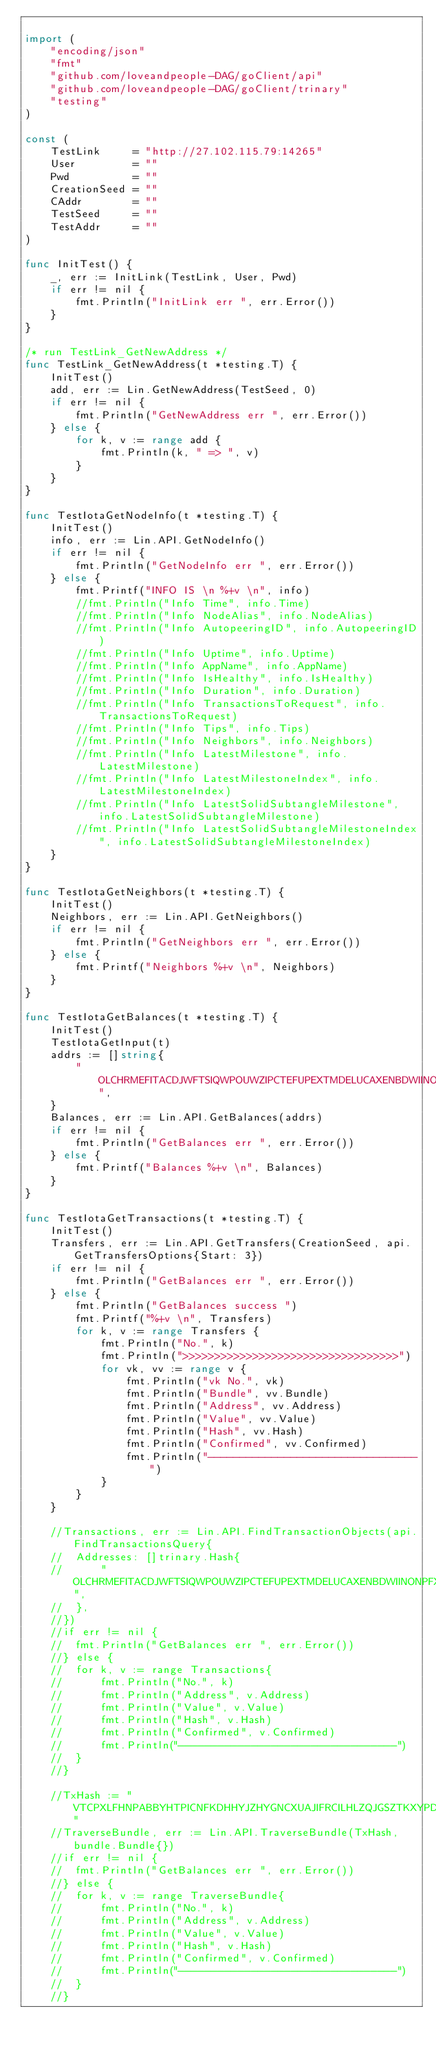<code> <loc_0><loc_0><loc_500><loc_500><_Go_>
import (
	"encoding/json"
	"fmt"
	"github.com/loveandpeople-DAG/goClient/api"
	"github.com/loveandpeople-DAG/goClient/trinary"
	"testing"
)

const (
	TestLink     = "http://27.102.115.79:14265"
	User         = ""
	Pwd          = ""
	CreationSeed = ""
	CAddr        = ""
	TestSeed     = ""
	TestAddr     = ""
)

func InitTest() {
	_, err := InitLink(TestLink, User, Pwd)
	if err != nil {
		fmt.Println("InitLink err ", err.Error())
	}
}

/* run TestLink_GetNewAddress */
func TestLink_GetNewAddress(t *testing.T) {
	InitTest()
	add, err := Lin.GetNewAddress(TestSeed, 0)
	if err != nil {
		fmt.Println("GetNewAddress err ", err.Error())
	} else {
		for k, v := range add {
			fmt.Println(k, " => ", v)
		}
	}
}

func TestIotaGetNodeInfo(t *testing.T) {
	InitTest()
	info, err := Lin.API.GetNodeInfo()
	if err != nil {
		fmt.Println("GetNodeInfo err ", err.Error())
	} else {
		fmt.Printf("INFO IS \n %+v \n", info)
		//fmt.Println("Info Time", info.Time)
		//fmt.Println("Info NodeAlias", info.NodeAlias)
		//fmt.Println("Info AutopeeringID", info.AutopeeringID)
		//fmt.Println("Info Uptime", info.Uptime)
		//fmt.Println("Info AppName", info.AppName)
		//fmt.Println("Info IsHealthy", info.IsHealthy)
		//fmt.Println("Info Duration", info.Duration)
		//fmt.Println("Info TransactionsToRequest", info.TransactionsToRequest)
		//fmt.Println("Info Tips", info.Tips)
		//fmt.Println("Info Neighbors", info.Neighbors)
		//fmt.Println("Info LatestMilestone", info.LatestMilestone)
		//fmt.Println("Info LatestMilestoneIndex", info.LatestMilestoneIndex)
		//fmt.Println("Info LatestSolidSubtangleMilestone", info.LatestSolidSubtangleMilestone)
		//fmt.Println("Info LatestSolidSubtangleMilestoneIndex", info.LatestSolidSubtangleMilestoneIndex)
	}
}

func TestIotaGetNeighbors(t *testing.T) {
	InitTest()
	Neighbors, err := Lin.API.GetNeighbors()
	if err != nil {
		fmt.Println("GetNeighbors err ", err.Error())
	} else {
		fmt.Printf("Neighbors %+v \n", Neighbors)
	}
}

func TestIotaGetBalances(t *testing.T) {
	InitTest()
	TestIotaGetInput(t)
	addrs := []string{
		"OLCHRMEFITACDJWFTSIQWPOUWZIPCTEFUPEXTMDELUCAXENBDWIINONPFXHRTIUMVAU99VNERAVVQYYXCWXPXRGAYD",
	}
	Balances, err := Lin.API.GetBalances(addrs)
	if err != nil {
		fmt.Println("GetBalances err ", err.Error())
	} else {
		fmt.Printf("Balances %+v \n", Balances)
	}
}

func TestIotaGetTransactions(t *testing.T) {
	InitTest()
	Transfers, err := Lin.API.GetTransfers(CreationSeed, api.GetTransfersOptions{Start: 3})
	if err != nil {
		fmt.Println("GetBalances err ", err.Error())
	} else {
		fmt.Println("GetBalances success ")
		fmt.Printf("%+v \n", Transfers)
		for k, v := range Transfers {
			fmt.Println("No.", k)
			fmt.Println(">>>>>>>>>>>>>>>>>>>>>>>>>>>>>>>>>>")
			for vk, vv := range v {
				fmt.Println("vk No.", vk)
				fmt.Println("Bundle", vv.Bundle)
				fmt.Println("Address", vv.Address)
				fmt.Println("Value", vv.Value)
				fmt.Println("Hash", vv.Hash)
				fmt.Println("Confirmed", vv.Confirmed)
				fmt.Println("---------------------------------")
			}
		}
	}

	//Transactions, err := Lin.API.FindTransactionObjects(api.FindTransactionsQuery{
	//	Addresses: []trinary.Hash{
	//		"OLCHRMEFITACDJWFTSIQWPOUWZIPCTEFUPEXTMDELUCAXENBDWIINONPFXHRTIUMVAU99VNERAVVQYYXC",
	//	},
	//})
	//if err != nil {
	//	fmt.Println("GetBalances err ", err.Error())
	//} else {
	//	for k, v := range Transactions{
	//		fmt.Println("No.", k)
	//		fmt.Println("Address", v.Address)
	//		fmt.Println("Value", v.Value)
	//		fmt.Println("Hash", v.Hash)
	//		fmt.Println("Confirmed", v.Confirmed)
	//		fmt.Println("---------------------------------")
	//	}
	//}

	//TxHash := "VTCPXLFHNPABBYHTPICNFKDHHYJZHYGNCXUAJIFRCILHLZQJGSZTKXYPDSFGODQVA9LJPNVZHJFFIFRTC"
	//TraverseBundle, err := Lin.API.TraverseBundle(TxHash, bundle.Bundle{})
	//if err != nil {
	//	fmt.Println("GetBalances err ", err.Error())
	//} else {
	//	for k, v := range TraverseBundle{
	//		fmt.Println("No.", k)
	//		fmt.Println("Address", v.Address)
	//		fmt.Println("Value", v.Value)
	//		fmt.Println("Hash", v.Hash)
	//		fmt.Println("Confirmed", v.Confirmed)
	//		fmt.Println("---------------------------------")
	//	}
	//}
</code> 